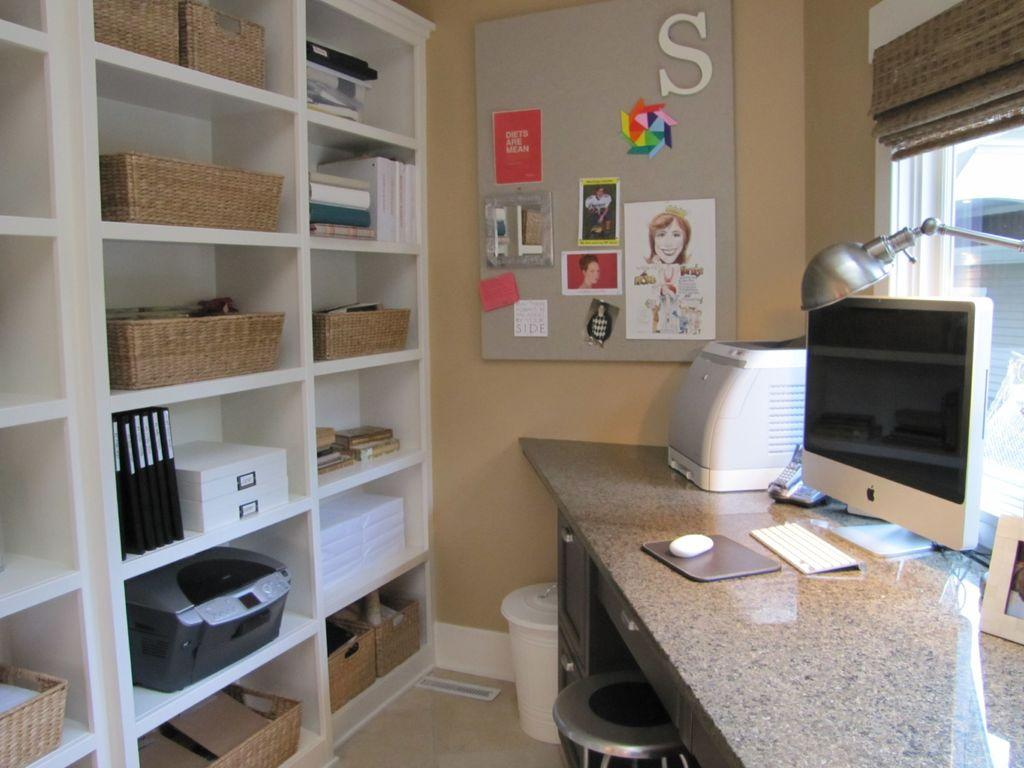<image>
Describe the image concisely. The letter S occupies a spot on the corner of a bulletin board. 